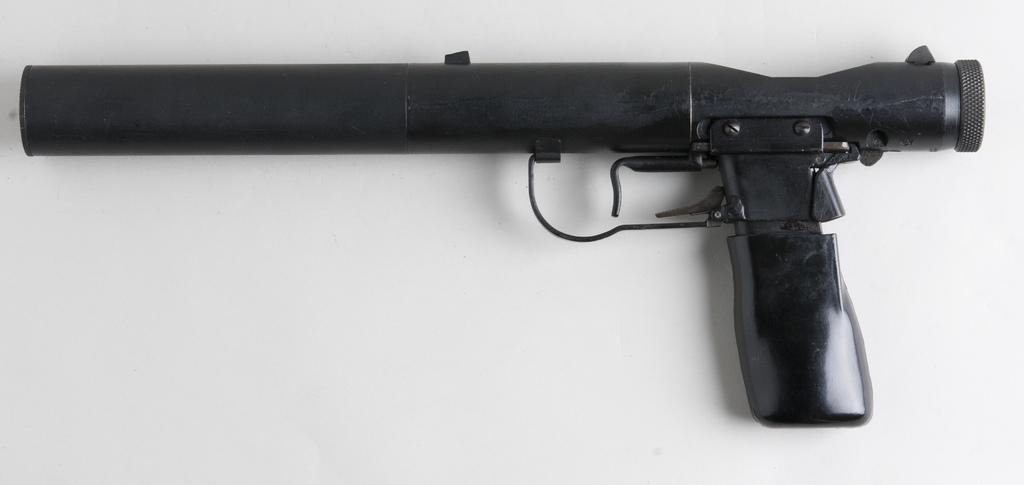What object is the main subject of the image? There is a gun in the image. Where is the gun placed in the image? The gun is placed on a white surface. What date is circled on the calendar in the image? There is no calendar present in the image. Is there a wound visible on the gun in the image? There is no wound visible on the gun in the image. 